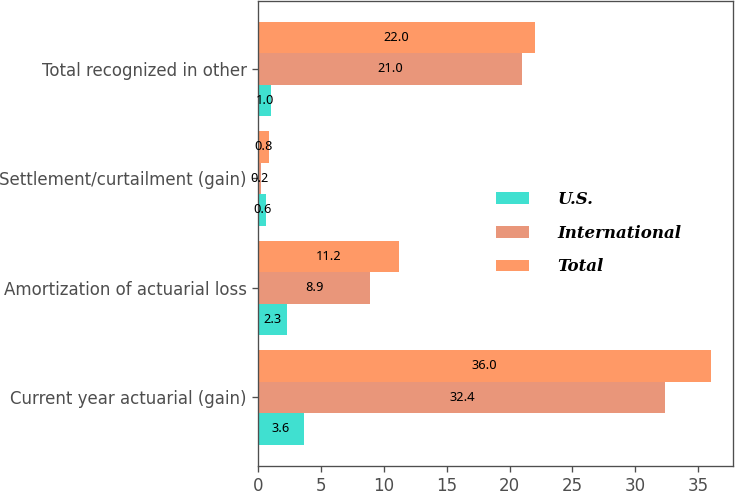<chart> <loc_0><loc_0><loc_500><loc_500><stacked_bar_chart><ecel><fcel>Current year actuarial (gain)<fcel>Amortization of actuarial loss<fcel>Settlement/curtailment (gain)<fcel>Total recognized in other<nl><fcel>U.S.<fcel>3.6<fcel>2.3<fcel>0.6<fcel>1<nl><fcel>International<fcel>32.4<fcel>8.9<fcel>0.2<fcel>21<nl><fcel>Total<fcel>36<fcel>11.2<fcel>0.8<fcel>22<nl></chart> 